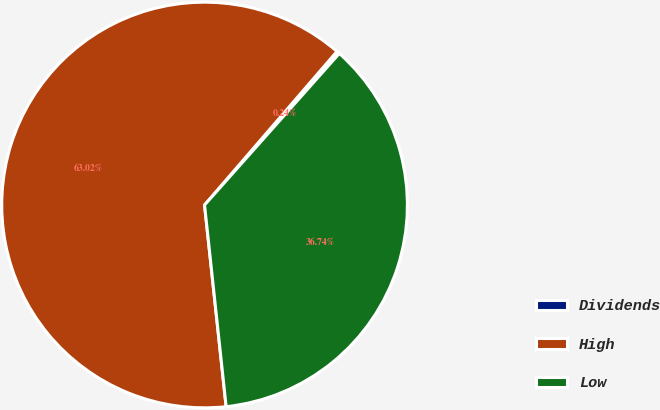Convert chart to OTSL. <chart><loc_0><loc_0><loc_500><loc_500><pie_chart><fcel>Dividends<fcel>High<fcel>Low<nl><fcel>0.24%<fcel>63.03%<fcel>36.74%<nl></chart> 